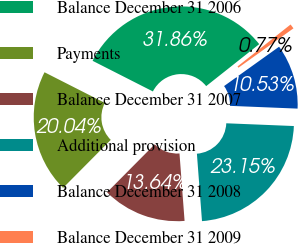Convert chart to OTSL. <chart><loc_0><loc_0><loc_500><loc_500><pie_chart><fcel>Balance December 31 2006<fcel>Payments<fcel>Balance December 31 2007<fcel>Additional provision<fcel>Balance December 31 2008<fcel>Balance December 31 2009<nl><fcel>31.86%<fcel>20.04%<fcel>13.64%<fcel>23.15%<fcel>10.53%<fcel>0.77%<nl></chart> 